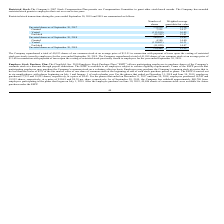According to Clearfield's financial document, What is the total repurchased shares of common stock for the year ended September 30, 2019? According to the financial document, 40,933. The relevant text states: "The Company repurchased a total of 40,933 shares of our common stock at an average price of $13.51 in connection with payment of taxes upon t..." Also, What is the total number of unvested shares as of September 30, 2019? According to the financial document, 130,440. The relevant text states: "Unvested shares as of September 30, 2019 130,440 $ 13.25..." Also, What is the use of the Clearfield, Inc. 2010 Employee Stock Purchase Plan? allows participating employees to purchase shares of the Company’s common stock at a discount through payroll deductions. The document states: ", Inc. 2010 Employee Stock Purchase Plan (“ESPP”) allows participating employees to purchase shares of the Company’s common stock at a discount throug..." Also, can you calculate: What is the total value of shares purchased for the ESPP phase ended December 31, 2018? Based on the calculation: 17,312*8.43, the result is 145940.16. This is based on the information: "r 31, 2018 and June 30, 2019, employees purchased 17,312 and 19,923 shares, respectively, at a price of $8.43. For the phases that ended on December 31, 201 r 31, 2018 and June 30, 2019, employees pur..." The key data points involved are: 17,312, 8.43. Also, can you calculate: What is the total value of repurchased stock for the year ended September 30, 2019? Based on the calculation: 40,933*13.51, the result is 553004.83. This is based on the information: "hares of our common stock at an average price of $13.51 in connection with payment of taxes upon the vesting of restricted stock previously issued to emplo The Company repurchased a total of 40,933 sh..." The key data points involved are: 13.51, 40,933. Also, can you calculate: What is the percentage change in the total value of shares purchased by employees from 30 June 2018 to 30 June 2019? To answer this question, I need to perform calculations using the financial data. The calculation is: ((19,923*8.43)-(15,932*9.39))/(15,932*9.39), which equals 12.27 (percentage). This is based on the information: "and June 30, 2019, employees purchased 17,312 and 19,923 shares, respectively, at a price of $8.43. For the phases that ended on December 31, 2017 and June and June 30, 2019, employees purchased 17,31..." The key data points involved are: 15,932, 19,923, 8.43. 